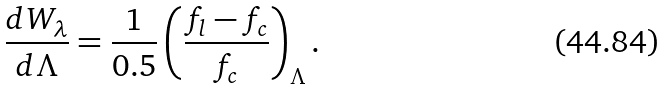Convert formula to latex. <formula><loc_0><loc_0><loc_500><loc_500>\frac { d W _ { \lambda } } { d \Lambda } = \frac { 1 } { 0 . 5 } \left ( \frac { f _ { l } - f _ { c } } { f _ { c } } \right ) _ { \Lambda } .</formula> 